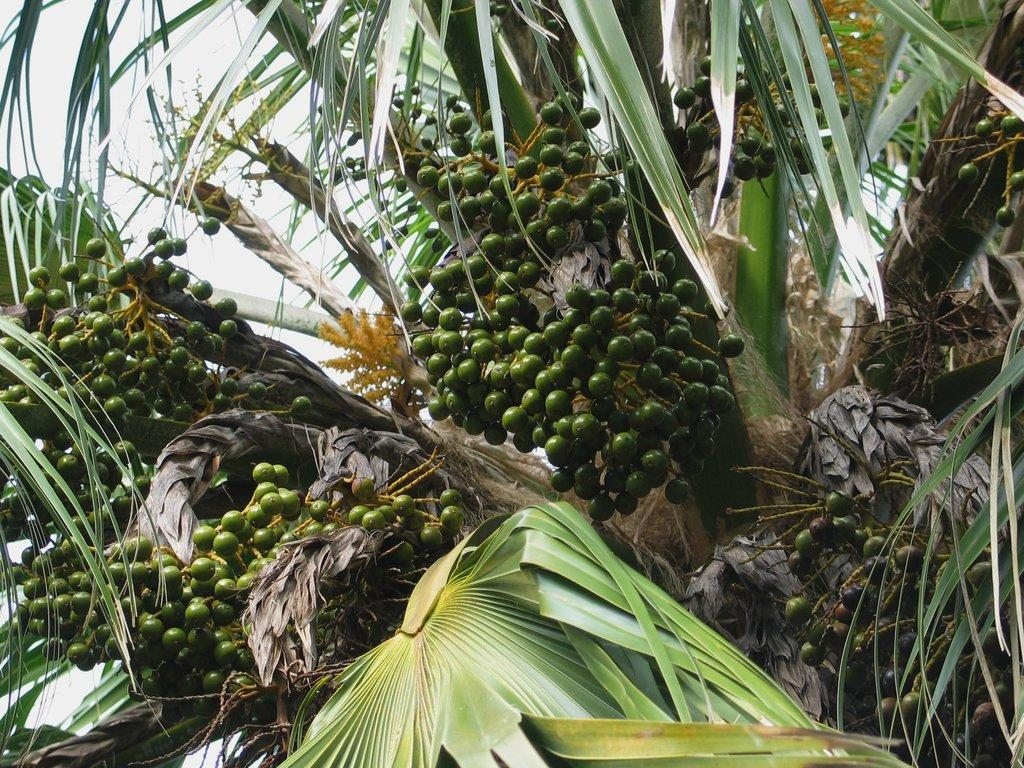What type of vegetation can be seen in the image? There are trees in the image. What color are the fruits on the trees? The fruits in the image are green in color. What is the color of the sky in the image? The sky is white in color. What type of button can be seen on the son's shirt in the image? There is no son or shirt present in the image; it only features trees, fruits, and a white sky. 